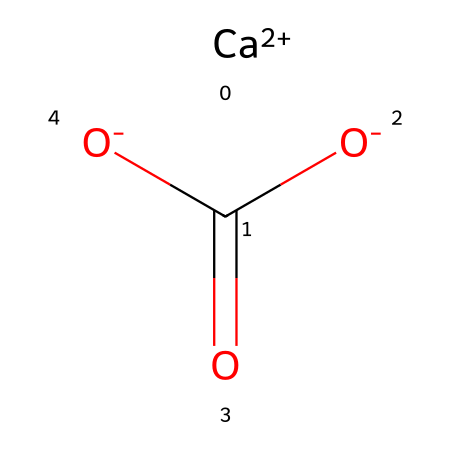What is the central atom in this chemical structure? The SMILES representation indicates the presence of a calcium cation denoted by [Ca+2], which is the central atom providing structure to the compound.
Answer: calcium How many oxygen atoms are present in this molecule? The chemical formula includes two oxygen atoms indicated by the two occurrences of [O-] in the SMILES representation.
Answer: two What type of bonding is present between the calcium and the carbonate ions? In the SMILES, the calcium is indicated to form ionic bonds with the negatively charged carbonate ions. This is inferred from [Ca+2] being a cation and the overall negative charge of the carbonate structure.
Answer: ionic What is the significance of the negative charges in the carbonate structure? The negative charges on the oxygen atoms indicate that they can participate in bonding with cations, which is essential for the stability and reactivity of the structure, particularly in limestone's weathering process.
Answer: stability How does this chemical contribute to the weathering of limestone? The presence of carbonate ions enables reactions with acids (like carbonic acid from rainfall), resulting in the dissolution of limestone over time, a key aspect of its weathering process.
Answer: dissolution What is the overall charge of the carbonate group in this structure? The carbonate group [C+0]([O-])(=O)[O-] shows that it has a -2 charge in total due to the two negatively charged oxygen atoms.
Answer: -2 